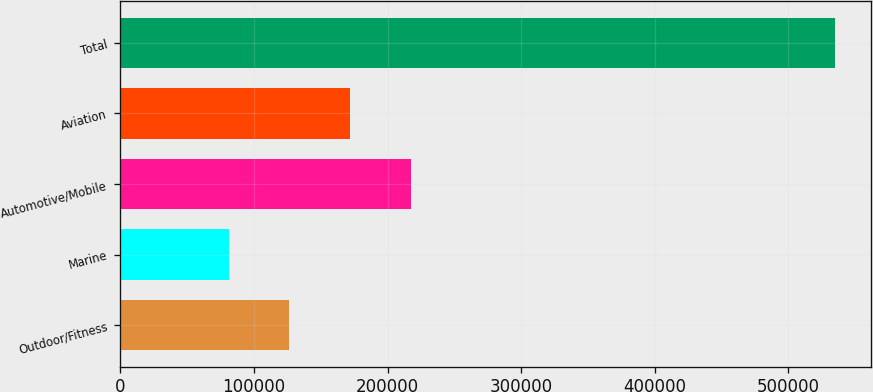Convert chart. <chart><loc_0><loc_0><loc_500><loc_500><bar_chart><fcel>Outdoor/Fitness<fcel>Marine<fcel>Automotive/Mobile<fcel>Aviation<fcel>Total<nl><fcel>126363<fcel>80951<fcel>217187<fcel>171775<fcel>535070<nl></chart> 